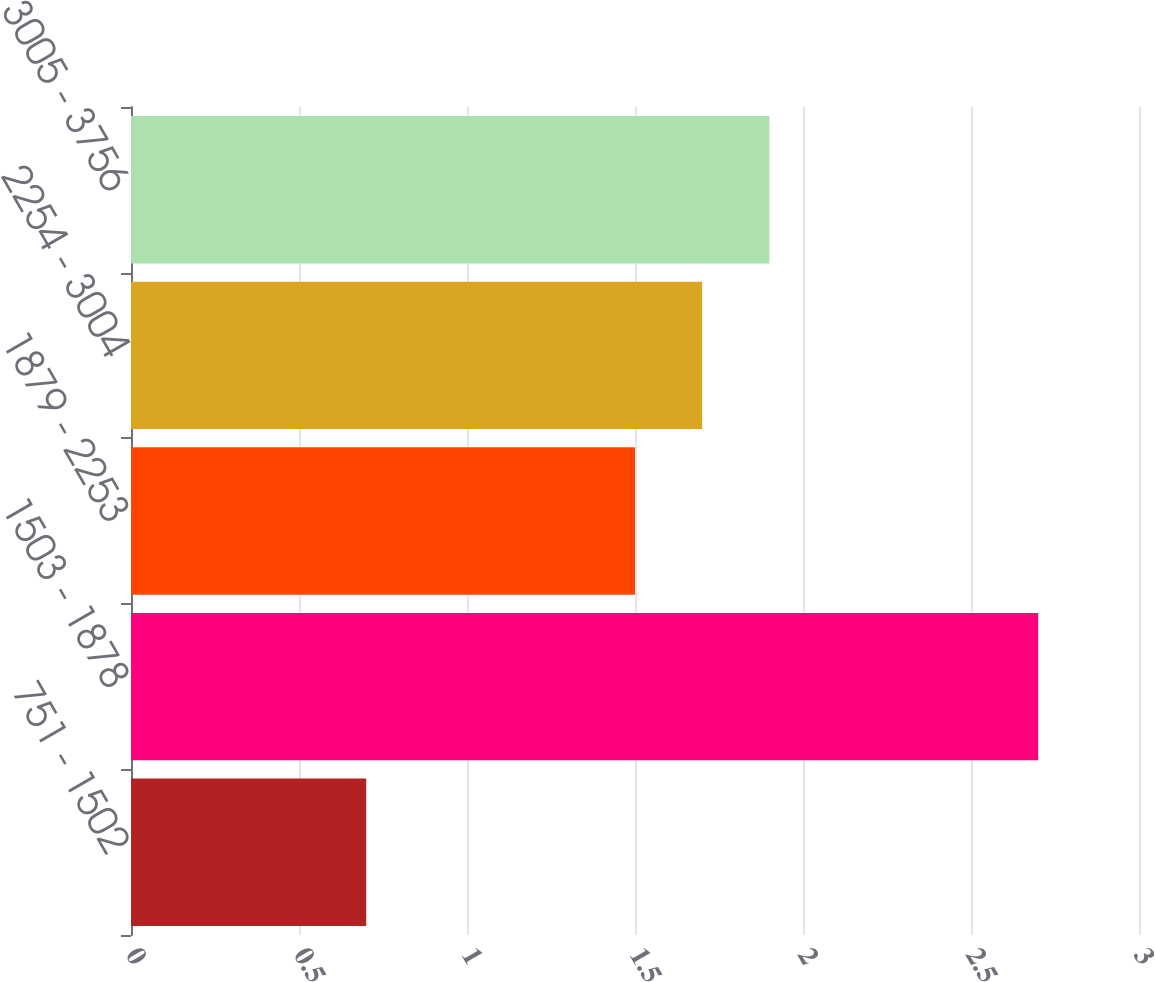Convert chart. <chart><loc_0><loc_0><loc_500><loc_500><bar_chart><fcel>751 - 1502<fcel>1503 - 1878<fcel>1879 - 2253<fcel>2254 - 3004<fcel>3005 - 3756<nl><fcel>0.7<fcel>2.7<fcel>1.5<fcel>1.7<fcel>1.9<nl></chart> 